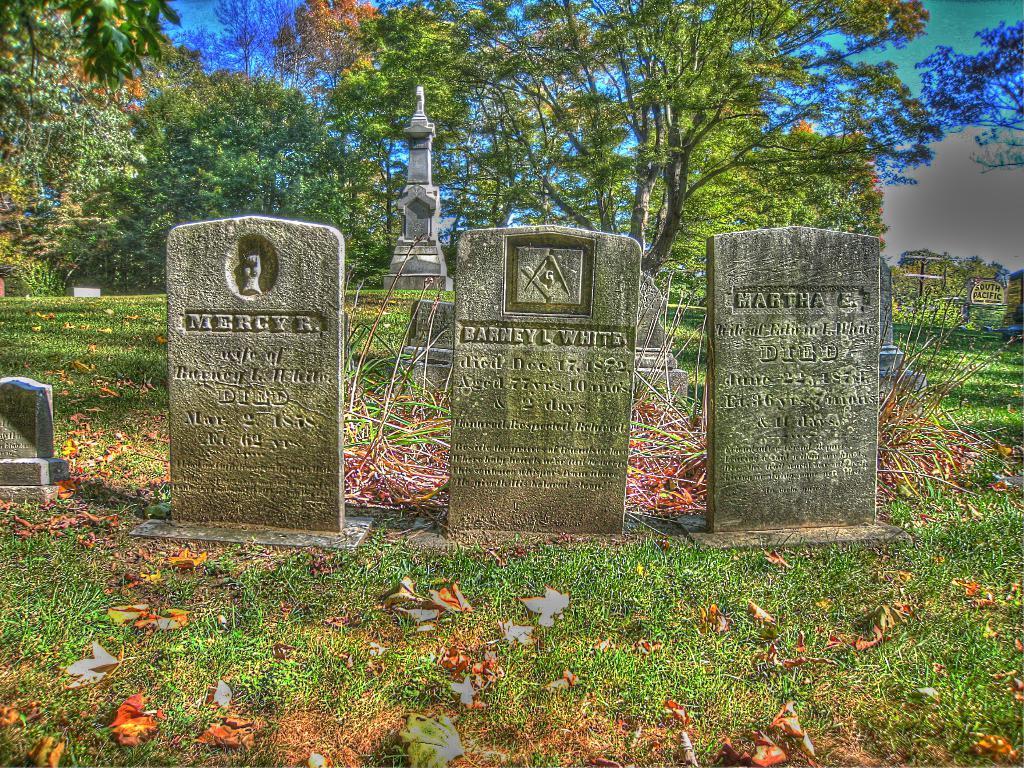Please provide a concise description of this image. In this image, we can see graveyard stones. There is a grass on the ground. There are some trees at the top of the image. 